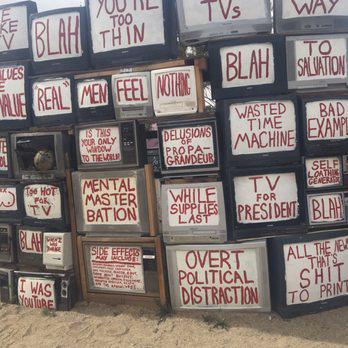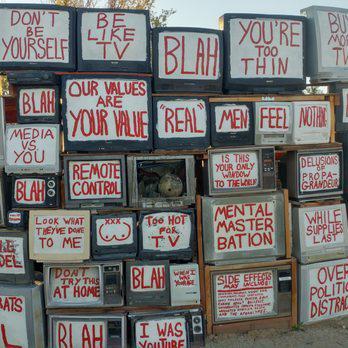The first image is the image on the left, the second image is the image on the right. Assess this claim about the two images: "A screen in the lower right says that democrats are evil, in at least one of the images.". Correct or not? Answer yes or no. No. 